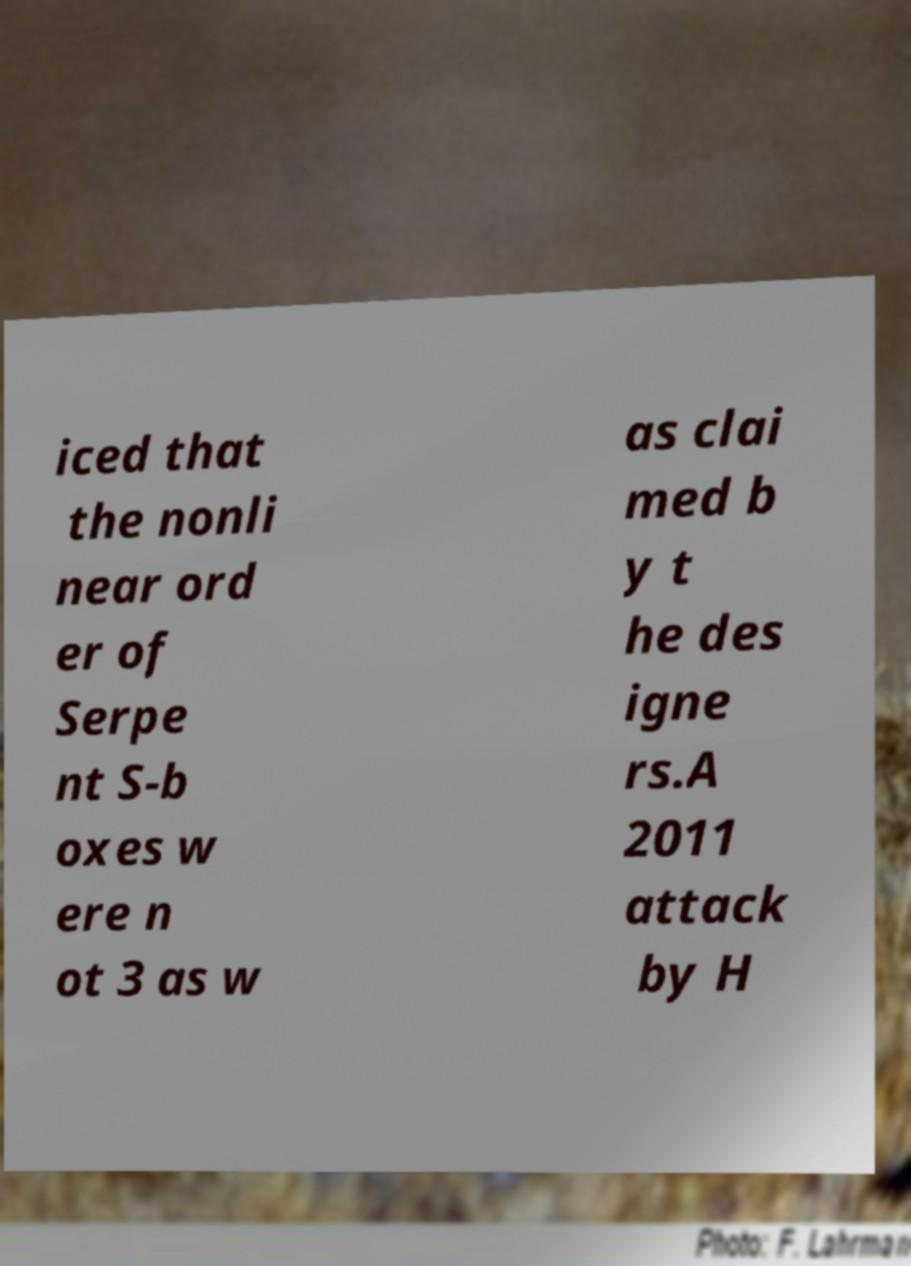There's text embedded in this image that I need extracted. Can you transcribe it verbatim? iced that the nonli near ord er of Serpe nt S-b oxes w ere n ot 3 as w as clai med b y t he des igne rs.A 2011 attack by H 